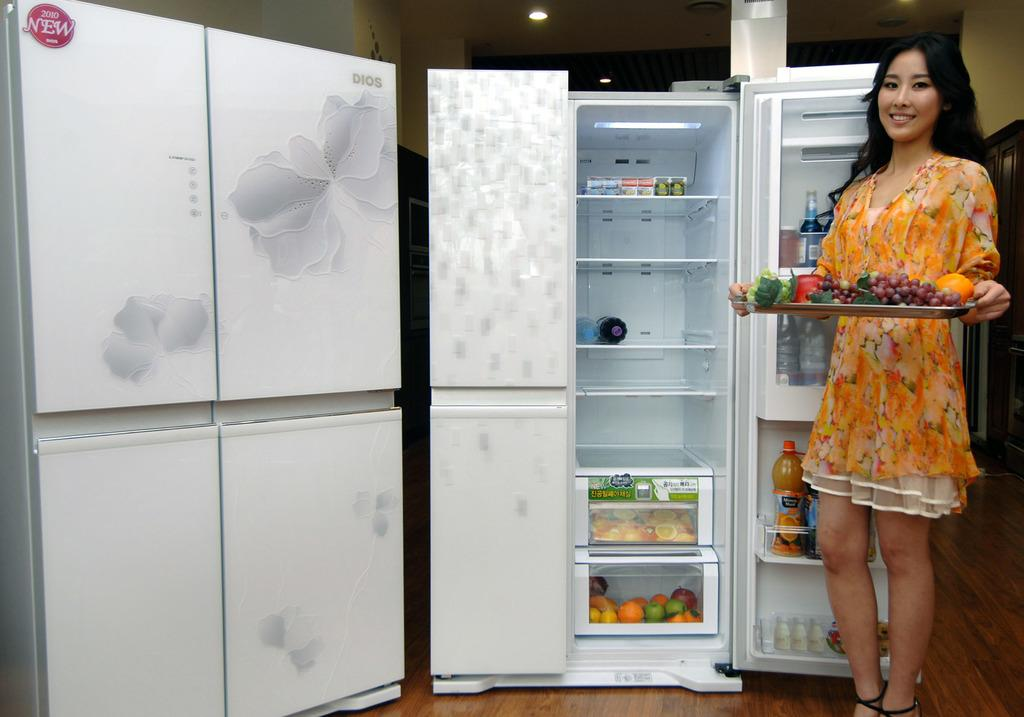<image>
Offer a succinct explanation of the picture presented. A refrigerator is displayed and advertised as being new for 2010. 